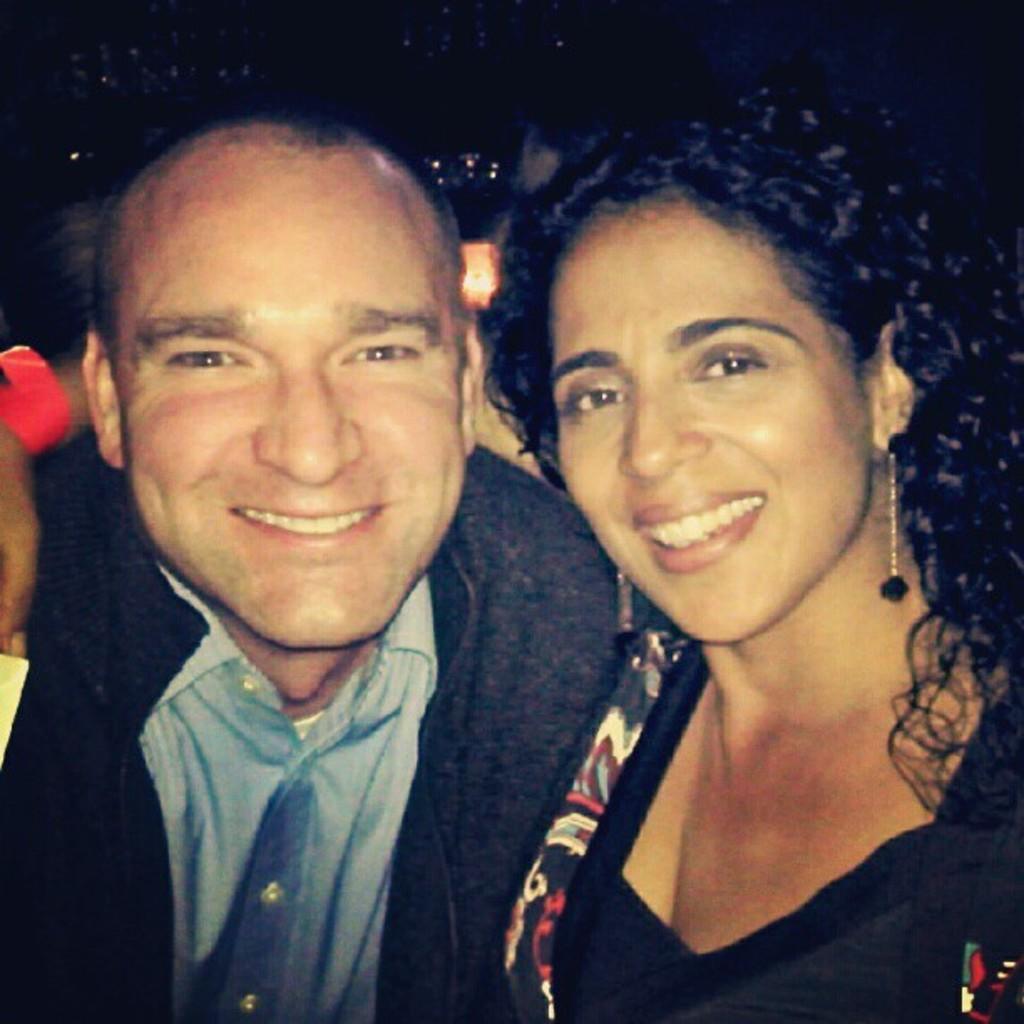Describe this image in one or two sentences. In this picture we can see there are two people smiling and behind the people there is a dark background. 